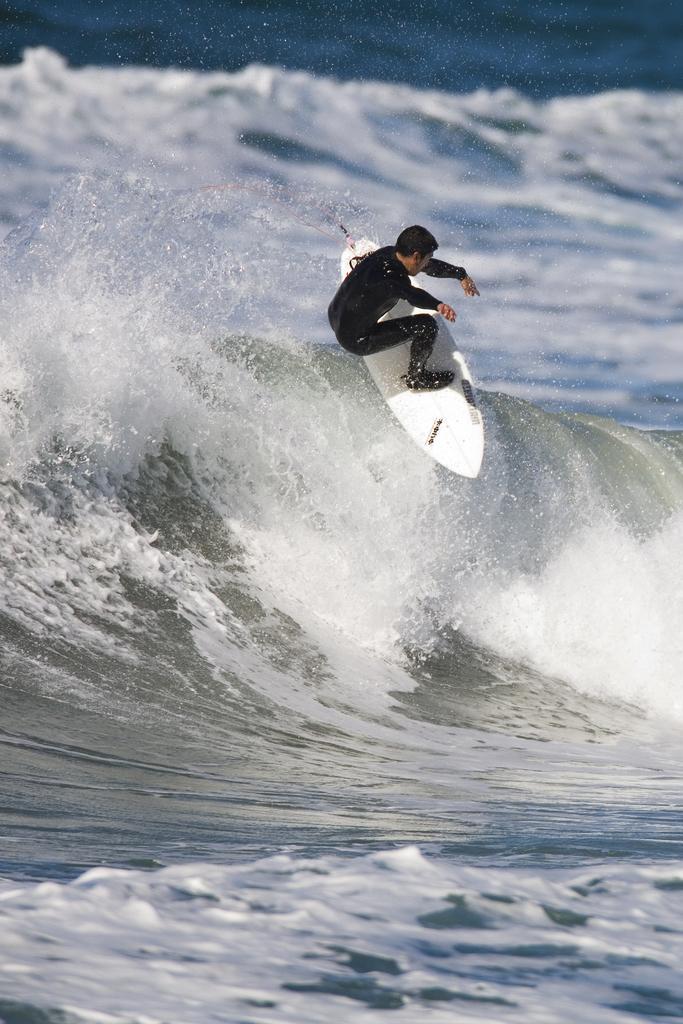Please provide a concise description of this image. In the image there is a man surfing on the waves and he is wearing black costume. 